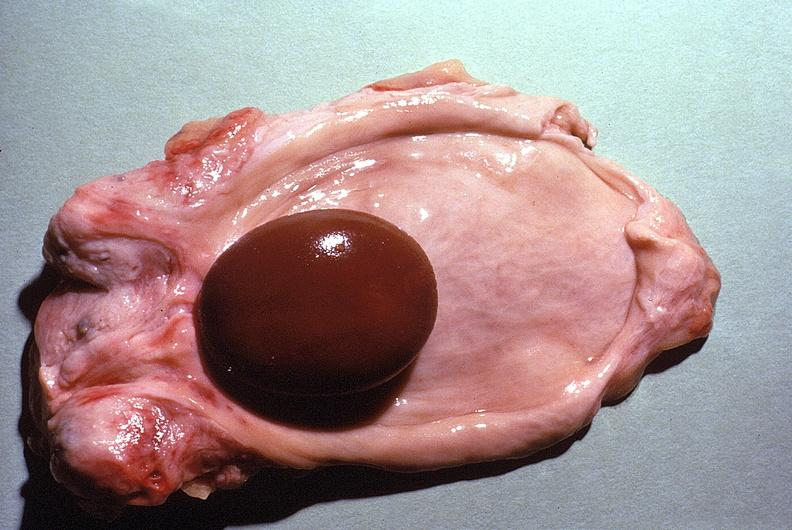where is this?
Answer the question using a single word or phrase. Urinary 